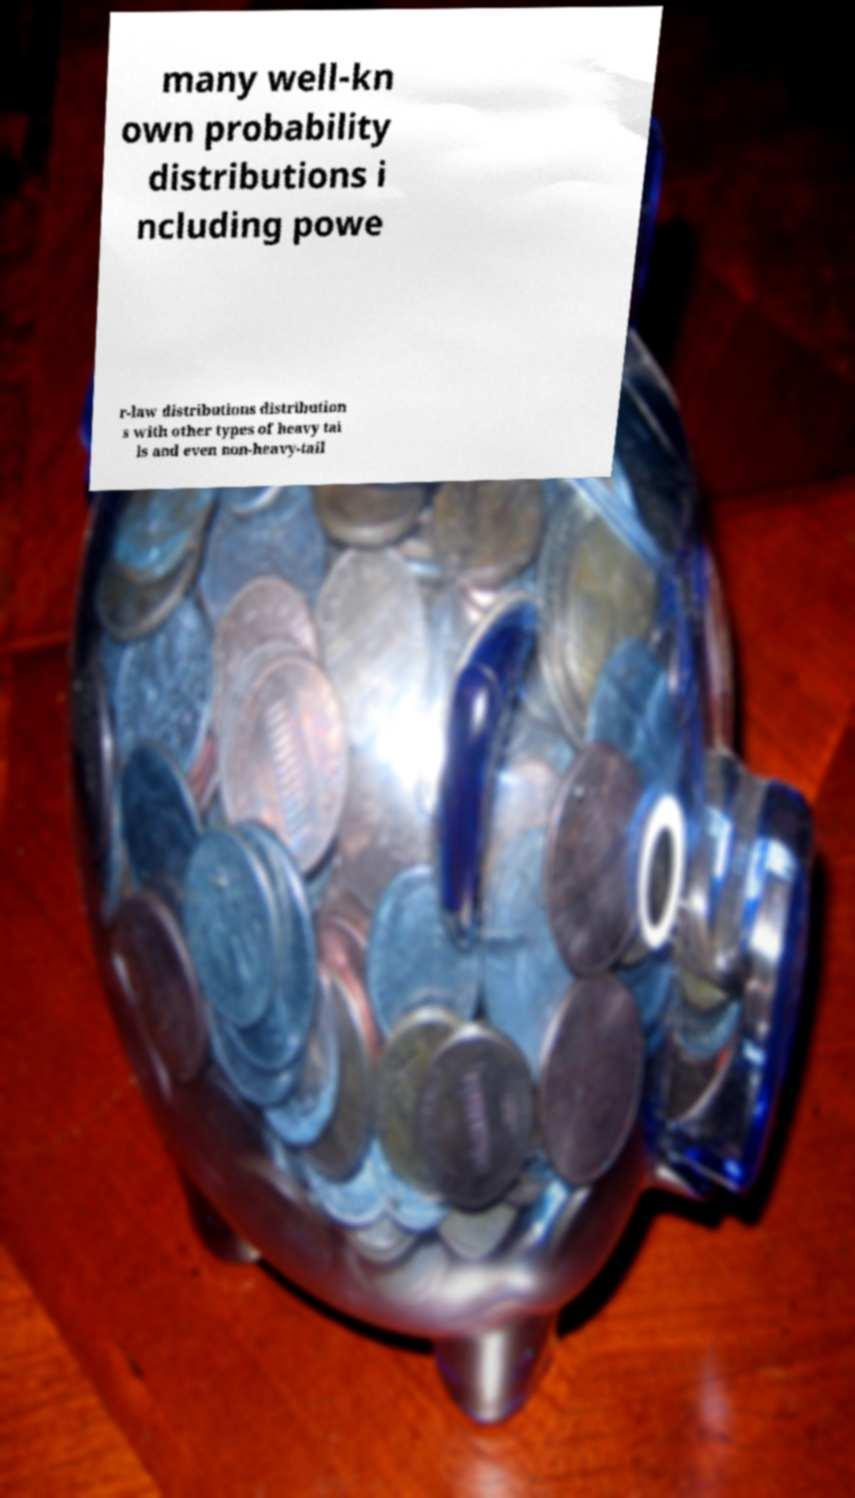Can you accurately transcribe the text from the provided image for me? many well-kn own probability distributions i ncluding powe r-law distributions distribution s with other types of heavy tai ls and even non-heavy-tail 